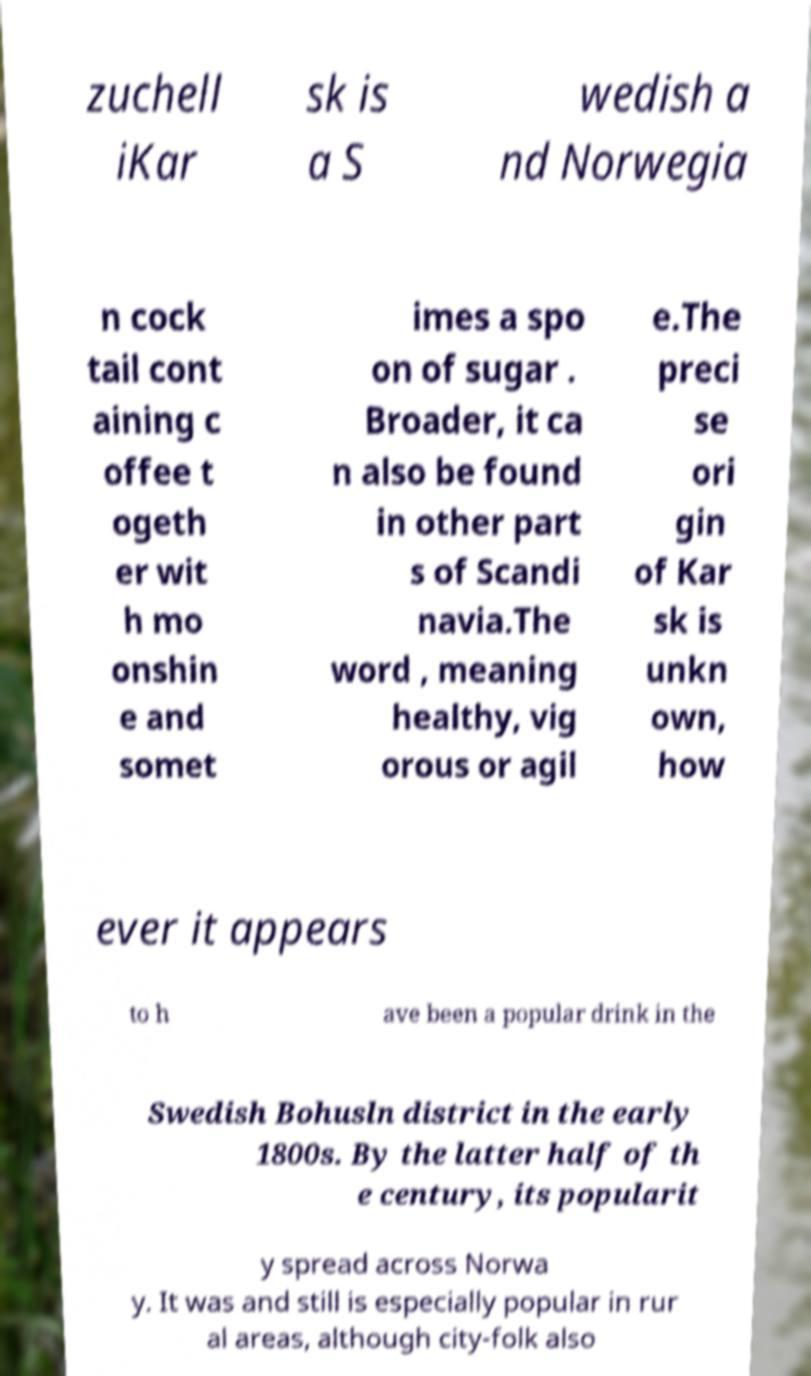Could you extract and type out the text from this image? zuchell iKar sk is a S wedish a nd Norwegia n cock tail cont aining c offee t ogeth er wit h mo onshin e and somet imes a spo on of sugar . Broader, it ca n also be found in other part s of Scandi navia.The word , meaning healthy, vig orous or agil e.The preci se ori gin of Kar sk is unkn own, how ever it appears to h ave been a popular drink in the Swedish Bohusln district in the early 1800s. By the latter half of th e century, its popularit y spread across Norwa y. It was and still is especially popular in rur al areas, although city-folk also 